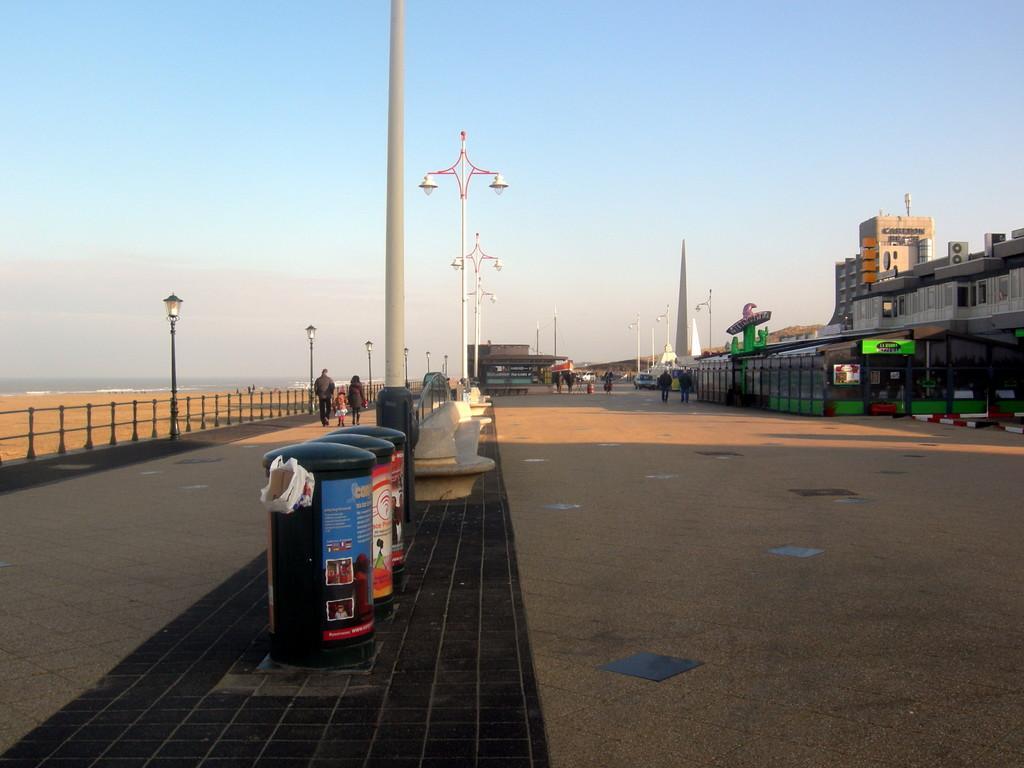Please provide a concise description of this image. We can see dust bins, pole and objects on the platform. We can see road, lights on poles and fence. There are people. Far we can see buildings, shed, vehicles and poles. In the background we can see water and sky. 